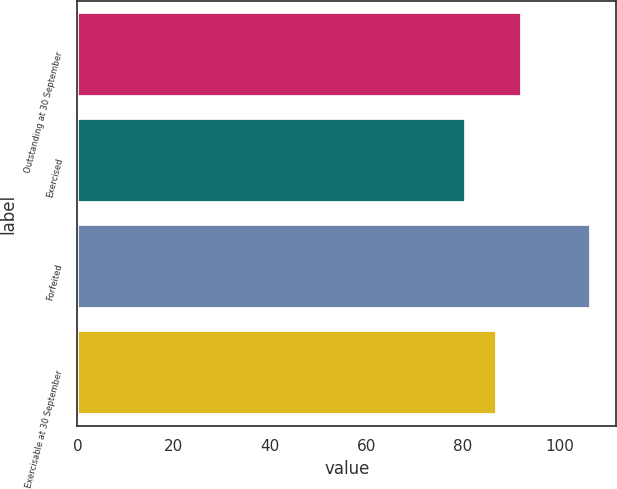Convert chart to OTSL. <chart><loc_0><loc_0><loc_500><loc_500><bar_chart><fcel>Outstanding at 30 September<fcel>Exercised<fcel>Forfeited<fcel>Exercisable at 30 September<nl><fcel>92.17<fcel>80.66<fcel>106.52<fcel>86.99<nl></chart> 